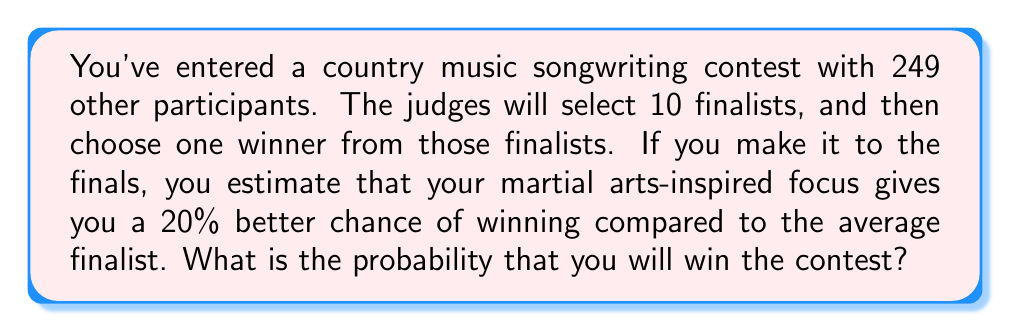Teach me how to tackle this problem. Let's approach this step-by-step:

1) First, we need to calculate the probability of becoming a finalist:
   $P(\text{finalist}) = \frac{10}{250} = \frac{1}{25} = 0.04$

2) Now, let's consider the probability of winning if you're a finalist. 
   If your chances are 20% better than average, we can set up this equation:
   $x + 9 \cdot \frac{x}{1.2} = 1$, where $x$ is your probability of winning as a finalist.

3) Solving this equation:
   $x + \frac{9x}{1.2} = 1$
   $1.2x + 9x = 1.2$
   $10.2x = 1.2$
   $x = \frac{1.2}{10.2} \approx 0.1176$

4) Now we can use the law of total probability:
   $P(\text{win}) = P(\text{win}|\text{finalist}) \cdot P(\text{finalist})$

5) Plugging in our values:
   $P(\text{win}) = 0.1176 \cdot 0.04 = 0.004704$
Answer: $\frac{1176}{250000} \approx 0.004704$ 